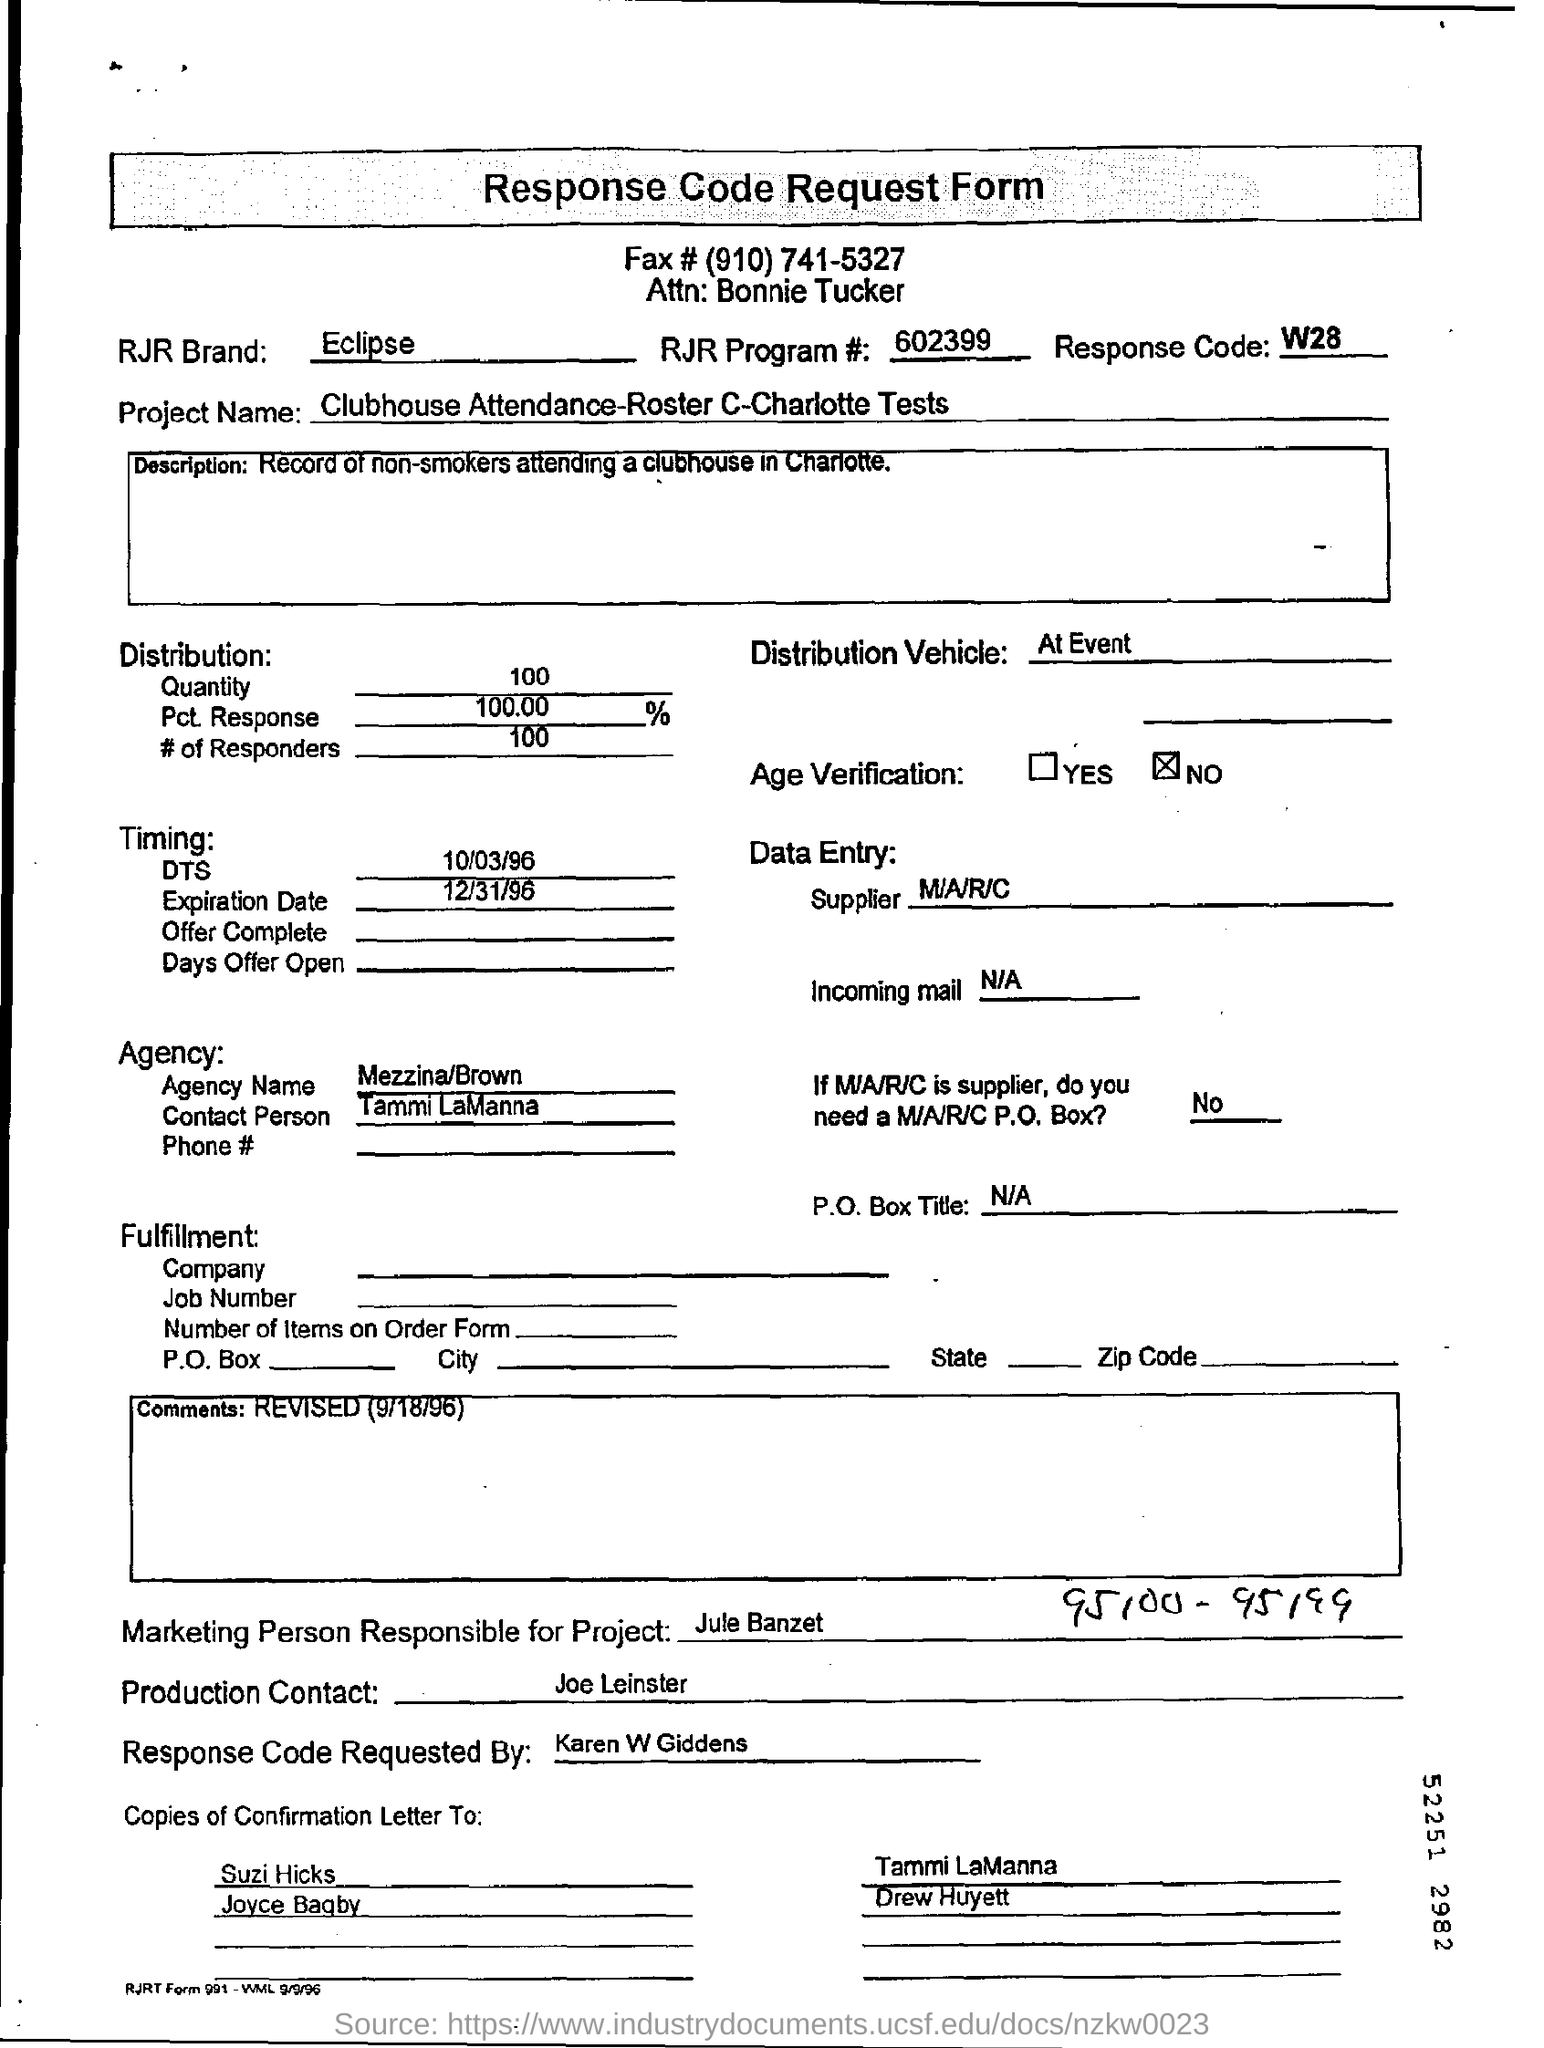List a handful of essential elements in this visual. The RJR Program number is 602399... The expiration date is December 31, 1996. It is Joe Leinster who is the production contact. Julie Banzet is the marketing professional in charge of the project. The supplier is M/A/R/C. 